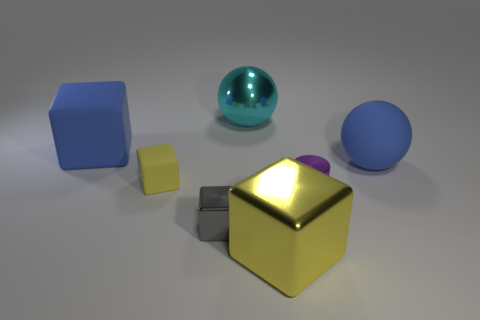There is a blue thing that is to the left of the block that is in front of the gray metallic cube; what shape is it? The blue object to the left of the yellow block, which is in front of the gray metallic cube, is a sphere. 